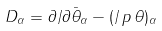Convert formula to latex. <formula><loc_0><loc_0><loc_500><loc_500>D _ { \alpha } = \partial / \partial \bar { \theta } _ { \alpha } - ( \slash \, p \, \theta ) _ { \alpha }</formula> 